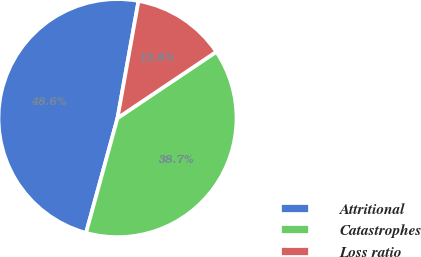Convert chart. <chart><loc_0><loc_0><loc_500><loc_500><pie_chart><fcel>Attritional<fcel>Catastrophes<fcel>Loss ratio<nl><fcel>48.57%<fcel>38.67%<fcel>12.77%<nl></chart> 